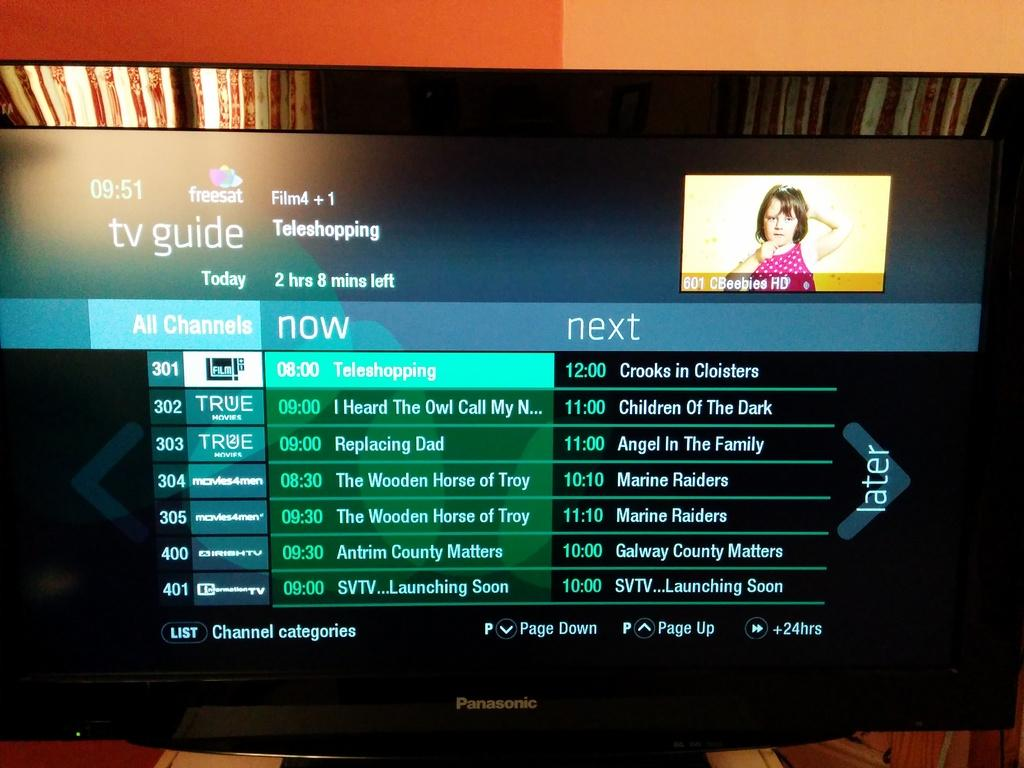Provide a one-sentence caption for the provided image. The tv guide is listing shows on True tv and Irish tv. 